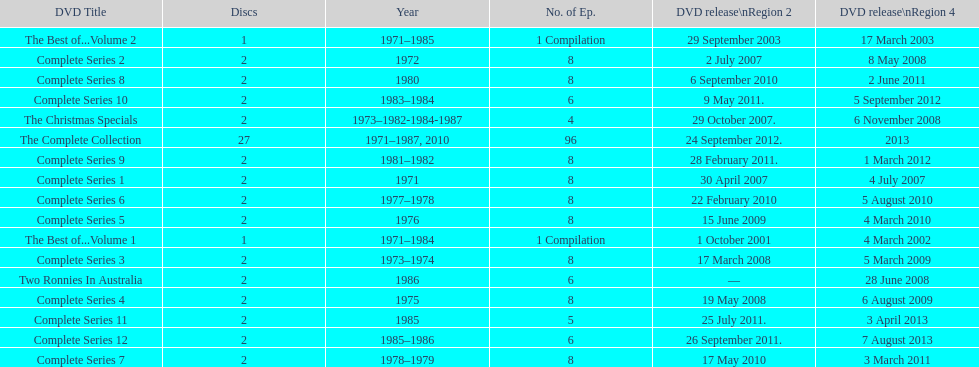Total number of episodes released in region 2 in 2007 20. 